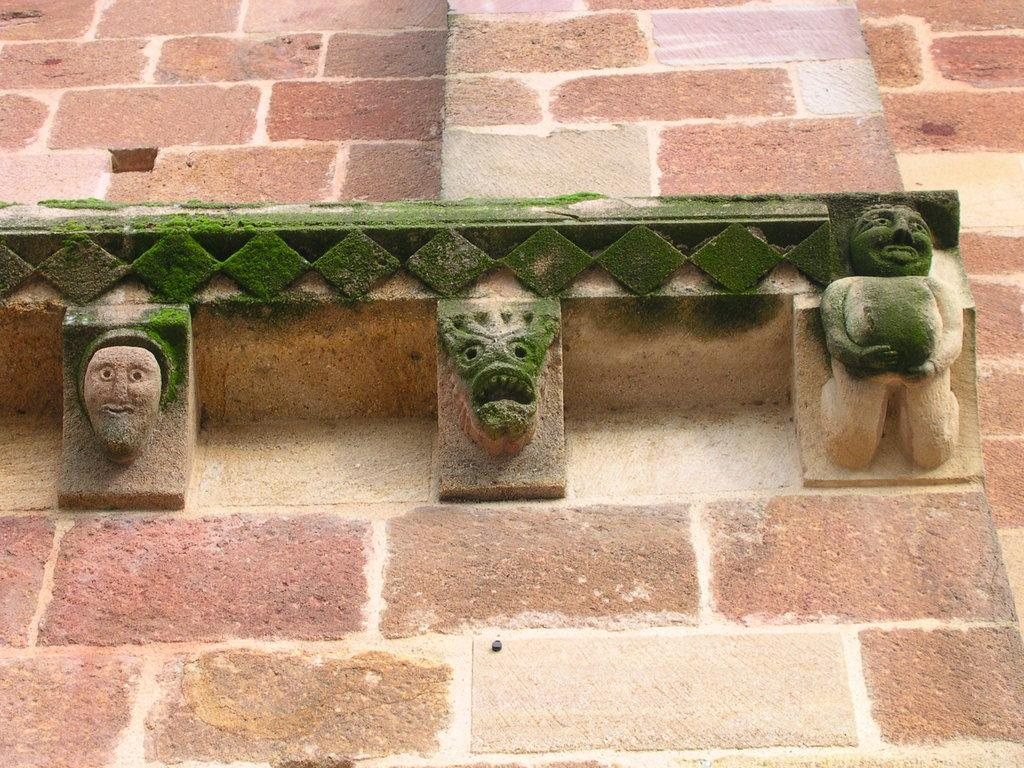What is depicted on the wall in the image? There are sculptures on the wall in the image. Can you describe the sculptures in more detail? Unfortunately, the provided facts do not offer more details about the sculptures. What might be the purpose of having sculptures on the wall? The purpose of having sculptures on the wall could be for decoration, artistic expression, or to convey a message or theme. How many pies are being served in the image? There is no mention of pies in the provided facts, and the image does not show any pies. 